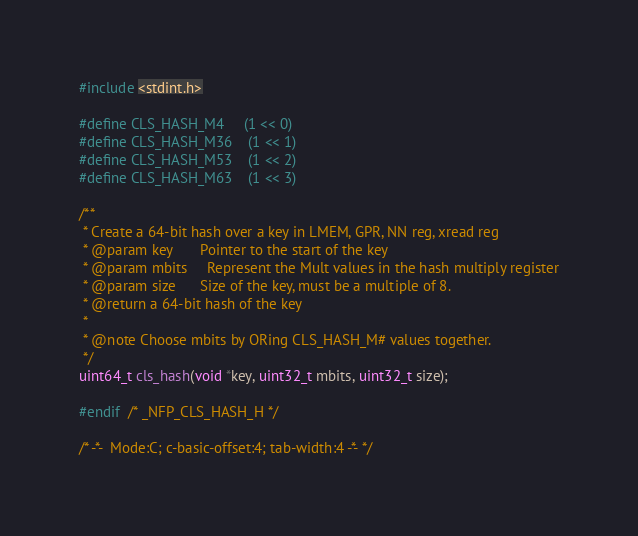<code> <loc_0><loc_0><loc_500><loc_500><_C_>
#include <stdint.h>

#define CLS_HASH_M4     (1 << 0)
#define CLS_HASH_M36    (1 << 1)
#define CLS_HASH_M53    (1 << 2)
#define CLS_HASH_M63    (1 << 3)

/**
 * Create a 64-bit hash over a key in LMEM, GPR, NN reg, xread reg
 * @param key       Pointer to the start of the key
 * @param mbits     Represent the Mult values in the hash multiply register
 * @param size      Size of the key, must be a multiple of 8.
 * @return a 64-bit hash of the key
 *
 * @note Choose mbits by ORing CLS_HASH_M# values together.
 */
uint64_t cls_hash(void *key, uint32_t mbits, uint32_t size);

#endif  /* _NFP_CLS_HASH_H */

/* -*-  Mode:C; c-basic-offset:4; tab-width:4 -*- */
</code> 